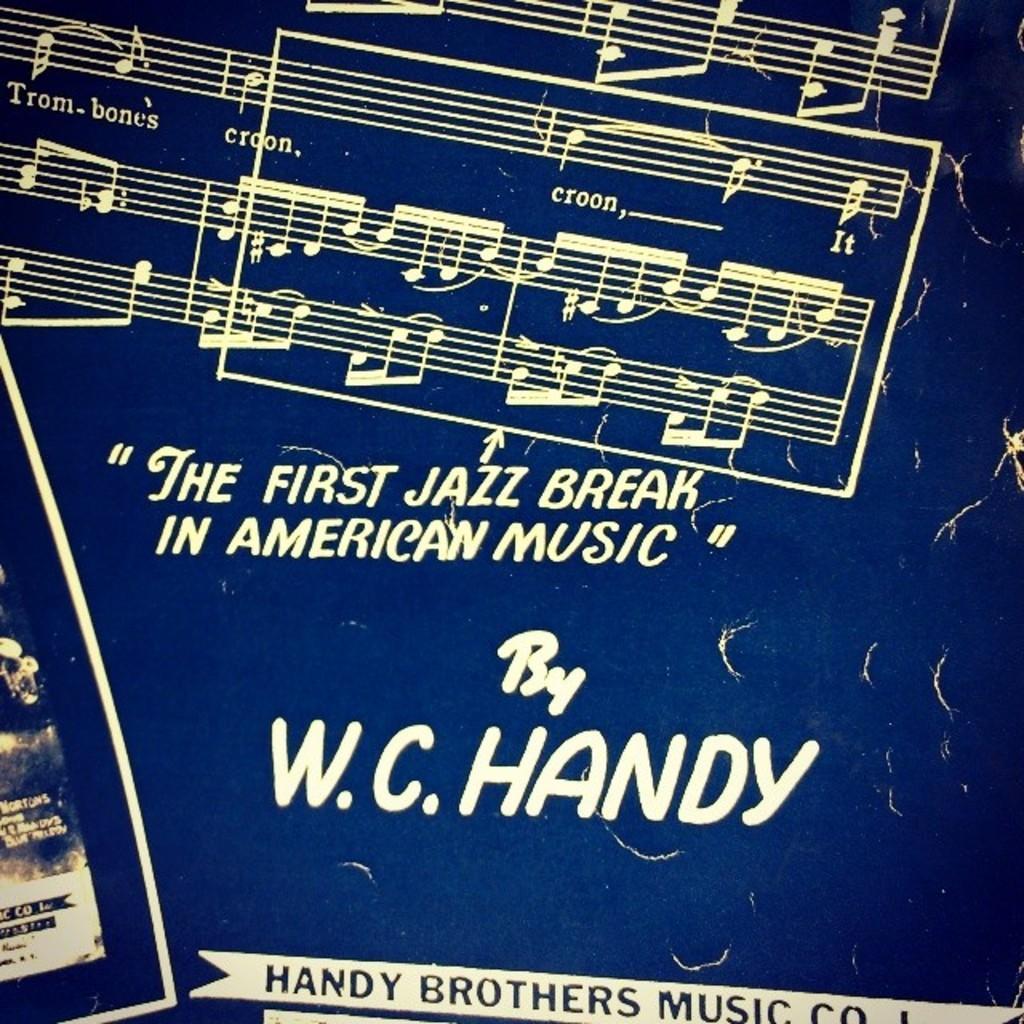Could you give a brief overview of what you see in this image? In the picture I can see a blue color post poster on which we can see some edited text and some notes of music. 